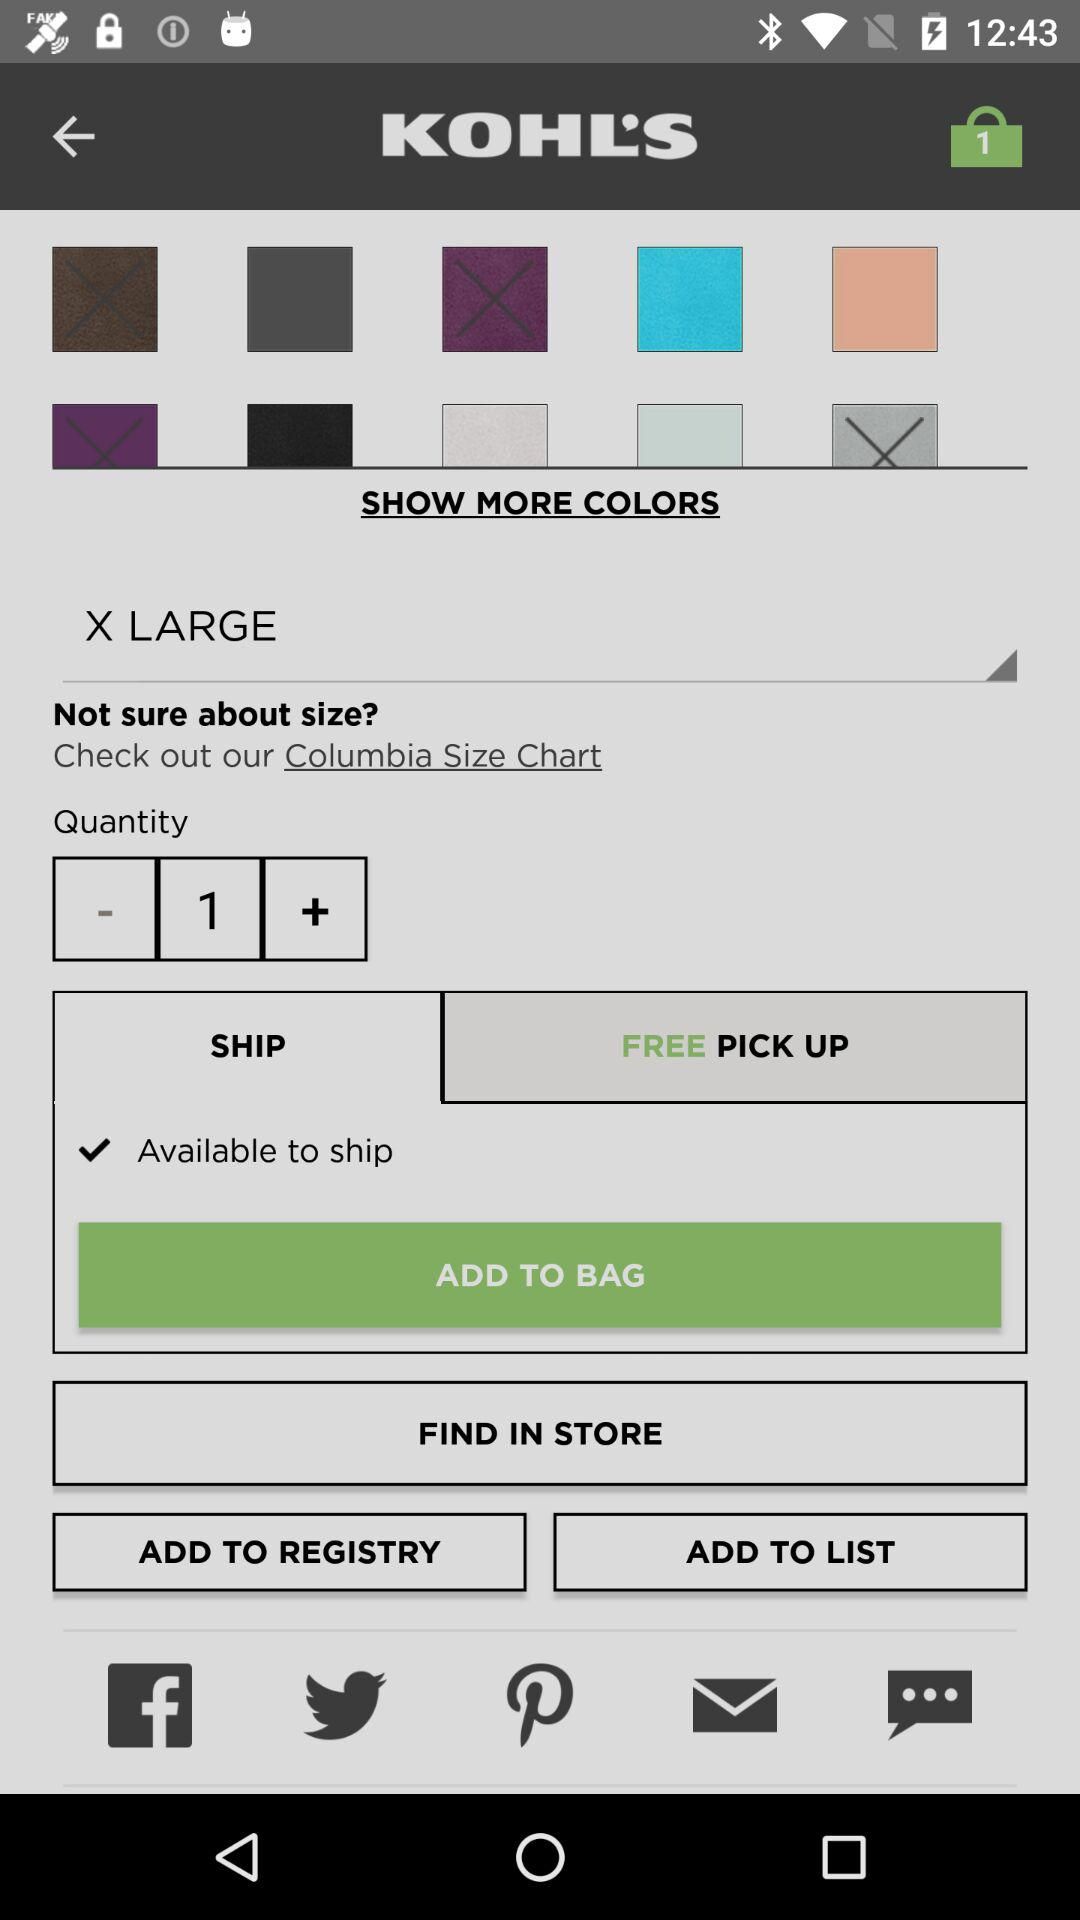What is the quantity? The quantity is 1. 